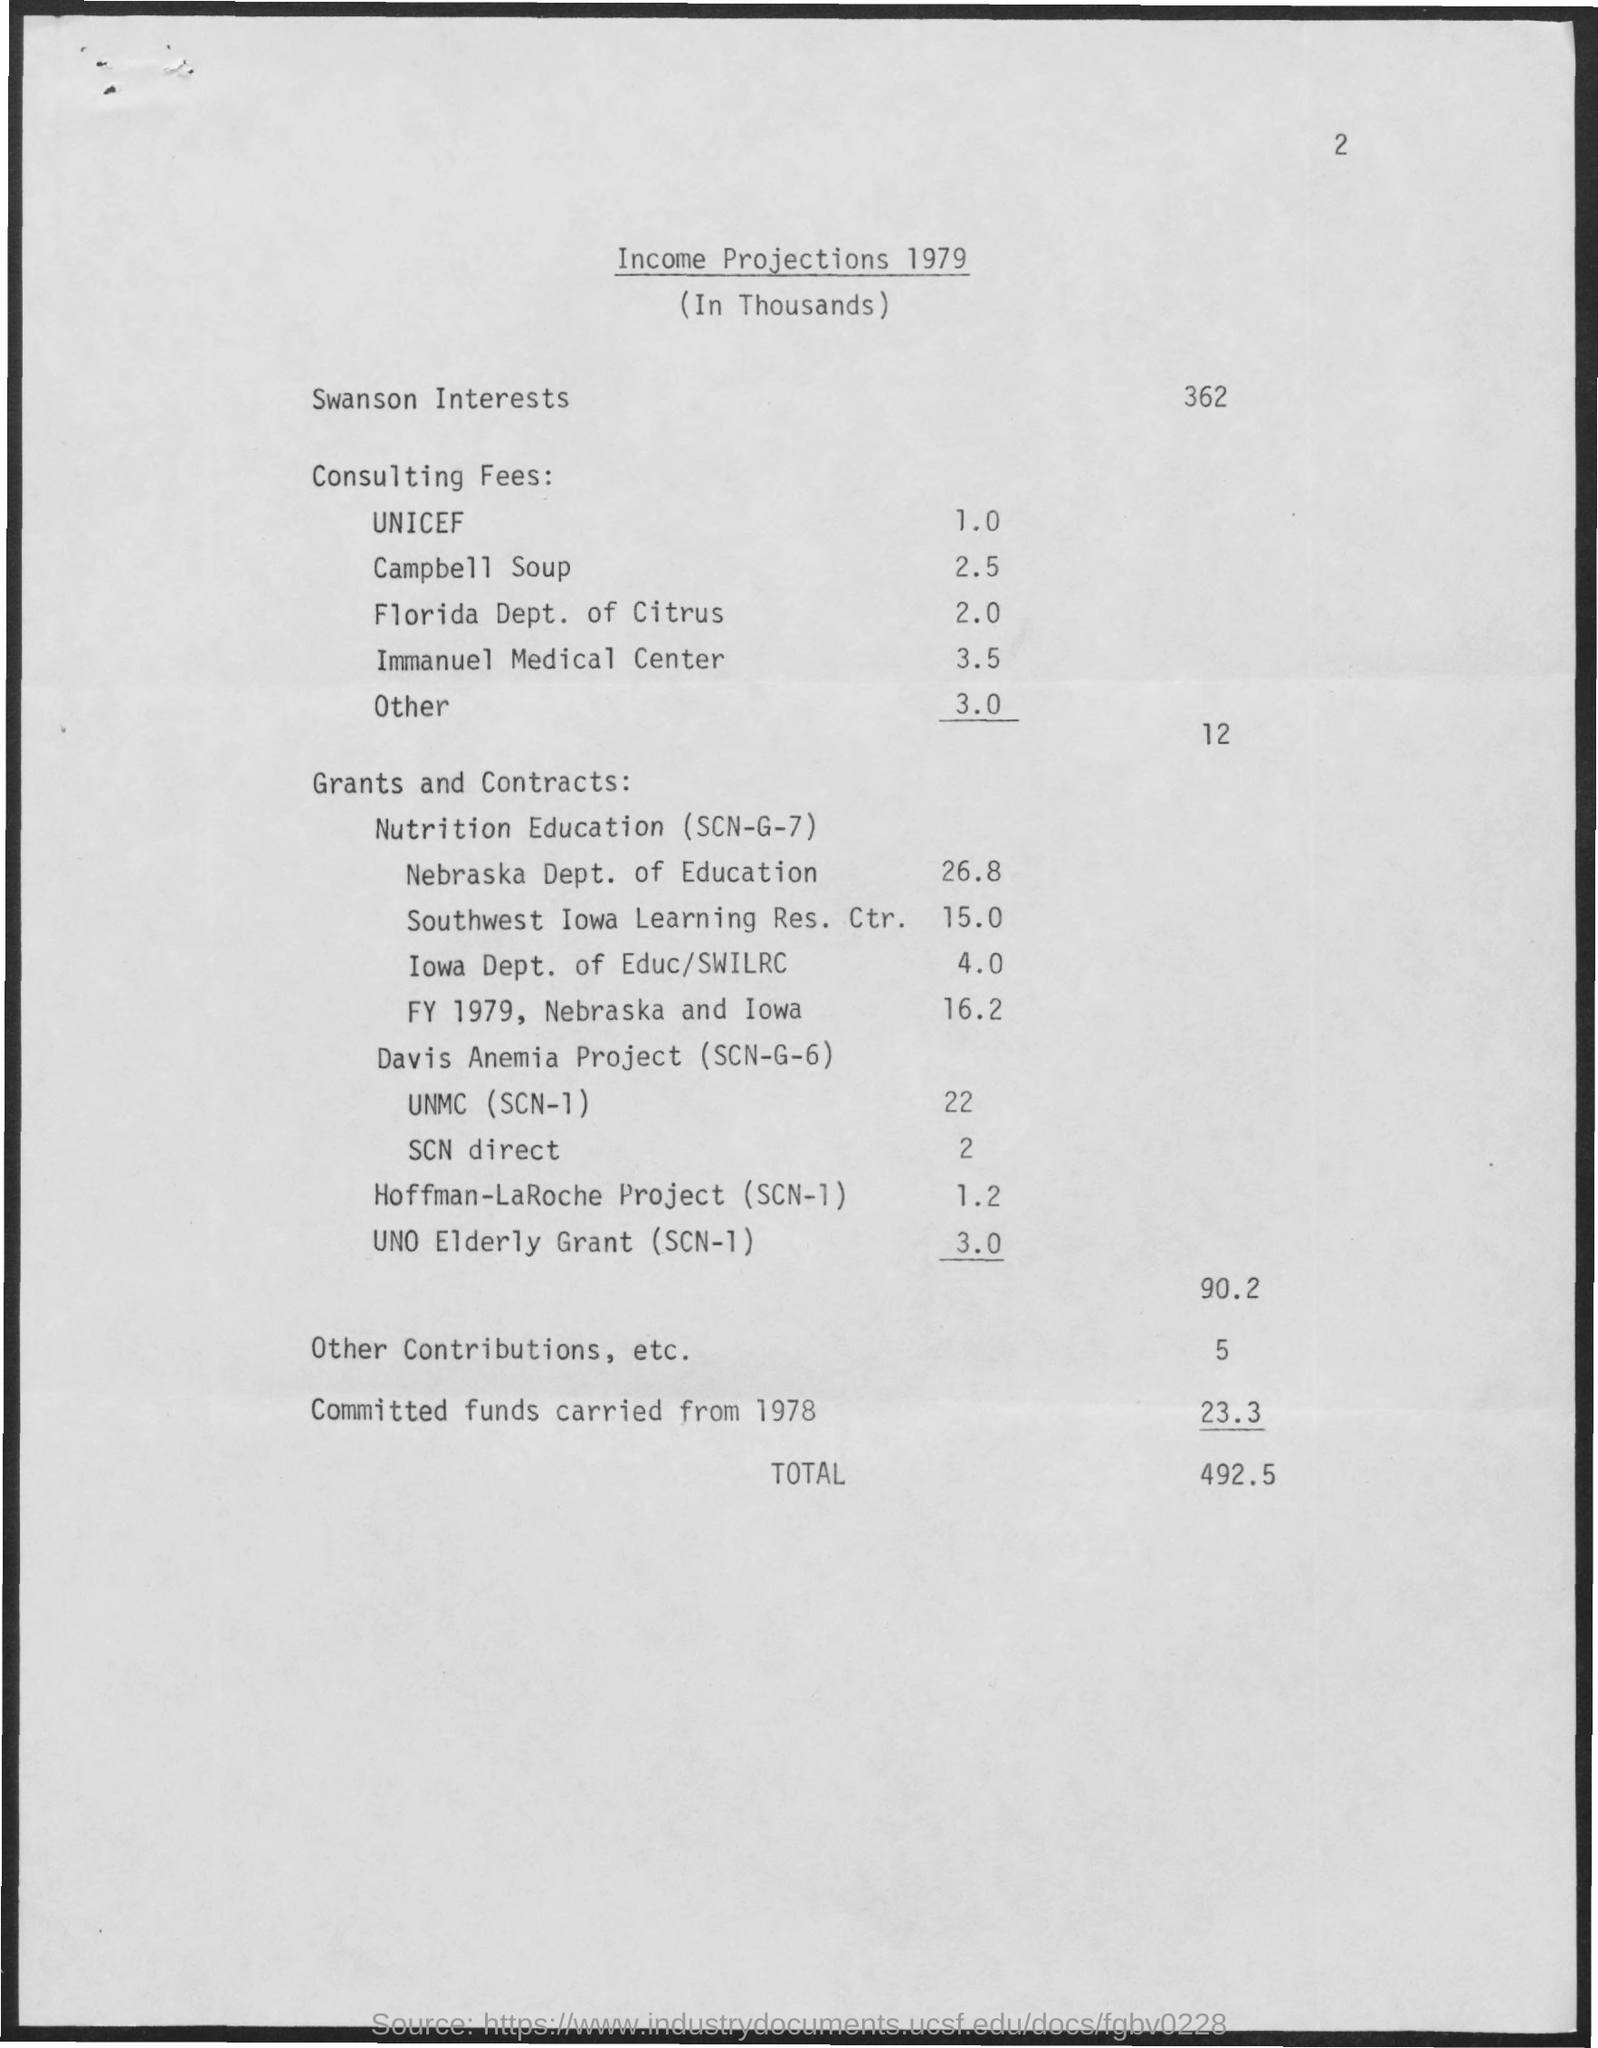What is the amount mentioned for unicef ?
Keep it short and to the point. 1.0. What is the value of campbell soup mentioned ?
Give a very brief answer. 2.5. What is the value of income for nebraska dept. of eductaion ?
Provide a short and direct response. 26,8. What is the total value mentioned ?
Offer a very short reply. 492.5. 